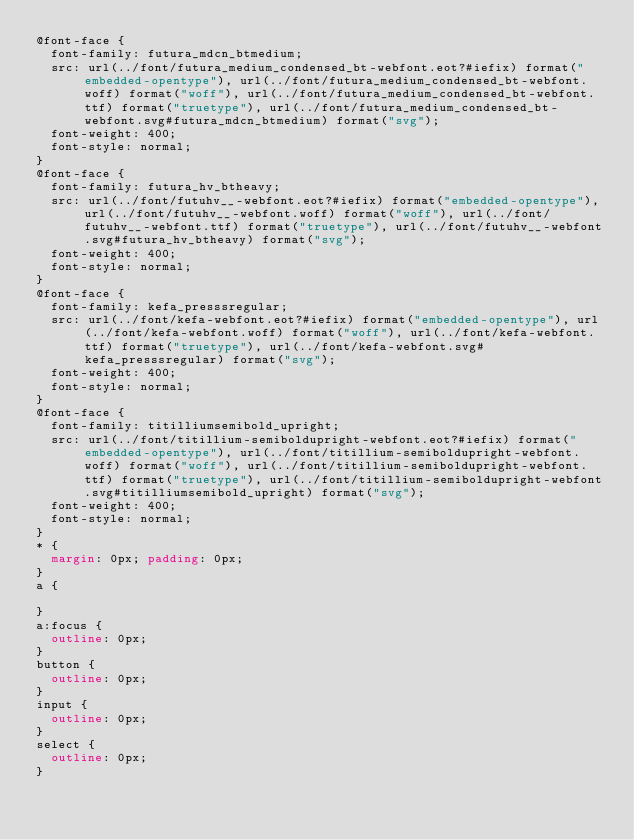<code> <loc_0><loc_0><loc_500><loc_500><_CSS_>@font-face {
	font-family: futura_mdcn_btmedium;
	src: url(../font/futura_medium_condensed_bt-webfont.eot?#iefix) format("embedded-opentype"), url(../font/futura_medium_condensed_bt-webfont.woff) format("woff"), url(../font/futura_medium_condensed_bt-webfont.ttf) format("truetype"), url(../font/futura_medium_condensed_bt-webfont.svg#futura_mdcn_btmedium) format("svg");
	font-weight: 400;
	font-style: normal;
}
@font-face {
	font-family: futura_hv_btheavy;
	src: url(../font/futuhv__-webfont.eot?#iefix) format("embedded-opentype"), url(../font/futuhv__-webfont.woff) format("woff"), url(../font/futuhv__-webfont.ttf) format("truetype"), url(../font/futuhv__-webfont.svg#futura_hv_btheavy) format("svg");
	font-weight: 400;
	font-style: normal;
}
@font-face {
	font-family: kefa_presssregular;
	src: url(../font/kefa-webfont.eot?#iefix) format("embedded-opentype"), url(../font/kefa-webfont.woff) format("woff"), url(../font/kefa-webfont.ttf) format("truetype"), url(../font/kefa-webfont.svg#kefa_presssregular) format("svg");
	font-weight: 400;
	font-style: normal;
}
@font-face {
	font-family: titilliumsemibold_upright;
	src: url(../font/titillium-semiboldupright-webfont.eot?#iefix) format("embedded-opentype"), url(../font/titillium-semiboldupright-webfont.woff) format("woff"), url(../font/titillium-semiboldupright-webfont.ttf) format("truetype"), url(../font/titillium-semiboldupright-webfont.svg#titilliumsemibold_upright) format("svg");
	font-weight: 400;
	font-style: normal;
}
* {
	margin: 0px; padding: 0px;
}
a {
	
}
a:focus {
	outline: 0px;
}
button {
	outline: 0px;
}
input {
	outline: 0px;
}
select {
	outline: 0px;
}</code> 